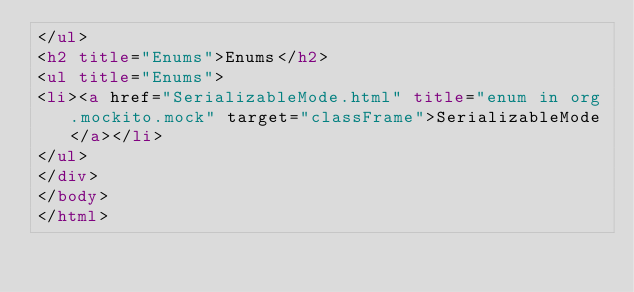Convert code to text. <code><loc_0><loc_0><loc_500><loc_500><_HTML_></ul>
<h2 title="Enums">Enums</h2>
<ul title="Enums">
<li><a href="SerializableMode.html" title="enum in org.mockito.mock" target="classFrame">SerializableMode</a></li>
</ul>
</div>
</body>
</html>
</code> 